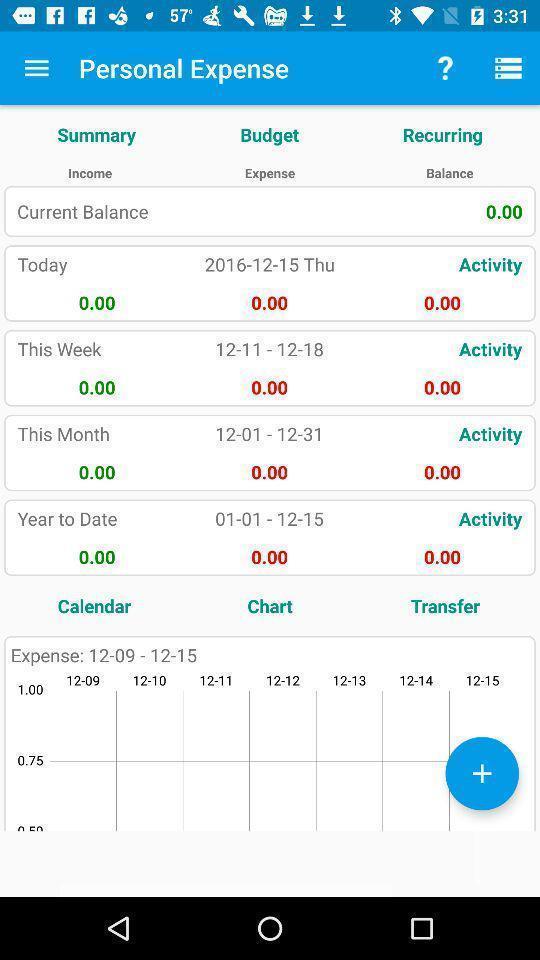What details can you identify in this image? Page showing about different stats for expenses. 